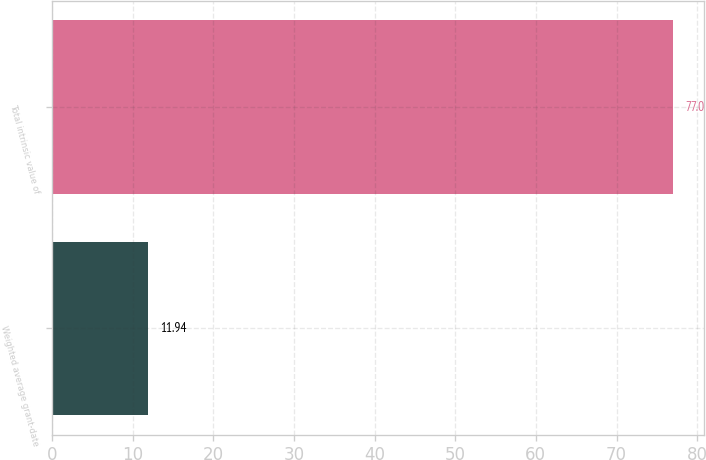<chart> <loc_0><loc_0><loc_500><loc_500><bar_chart><fcel>Weighted average grant-date<fcel>Total intrinsic value of<nl><fcel>11.94<fcel>77<nl></chart> 